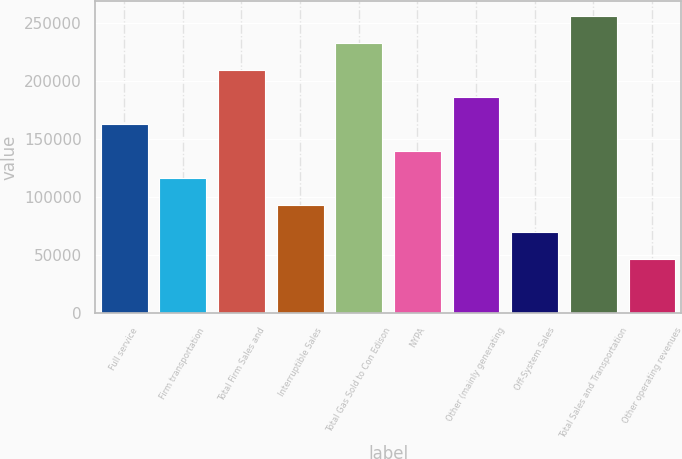<chart> <loc_0><loc_0><loc_500><loc_500><bar_chart><fcel>Full service<fcel>Firm transportation<fcel>Total Firm Sales and<fcel>Interruptible Sales<fcel>Total Gas Sold to Con Edison<fcel>NYPA<fcel>Other (mainly generating<fcel>Off-System Sales<fcel>Total Sales and Transportation<fcel>Other operating revenues<nl><fcel>163088<fcel>116496<fcel>209681<fcel>93199.8<fcel>232977<fcel>139792<fcel>186385<fcel>69903.6<fcel>256273<fcel>46607.4<nl></chart> 